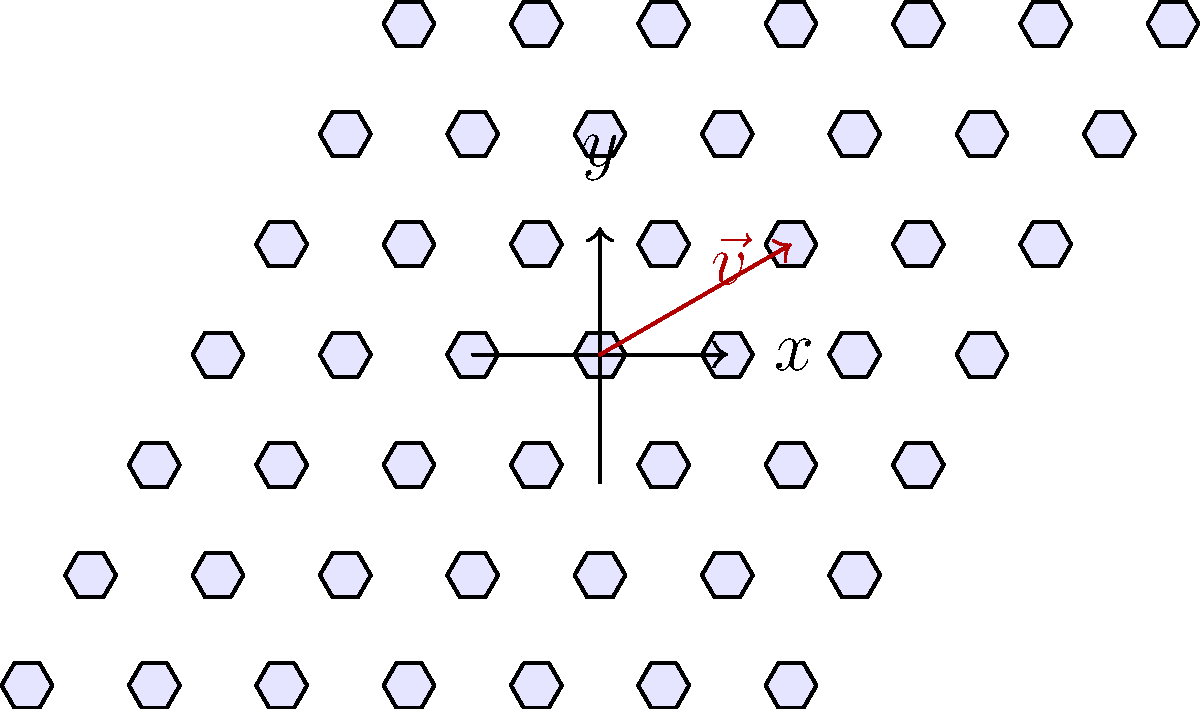In Islamic art, tessellating hexagonal patterns are often used in mosque tile designs. Consider the hexagonal tiling shown above. If we apply a translation by vector $\vec{v} = (1.5, 0.866)$ to this pattern, how many complete hexagons in the original pattern will be moved entirely outside the region shown in the diagram? To solve this problem, we need to analyze the effect of the translation vector on the hexagonal pattern:

1) First, observe that the hexagonal pattern is centered at the origin (0,0).

2) The translation vector $\vec{v} = (1.5, 0.866)$ moves the pattern 1.5 units in the x-direction and 0.866 units in the y-direction.

3) In the hexagonal tiling, each hexagon is surrounded by 6 others. The centers of these surrounding hexagons are at distances of 1 unit from the central hexagon.

4) The magnitude of the translation vector is:
   $\sqrt{1.5^2 + 0.866^2} \approx 1.732$

5) This magnitude is greater than the distance between the centers of adjacent hexagons (which is 1), but less than twice this distance.

6) This means that the translation will move hexagons beyond their immediate neighbors, but not beyond the second ring of hexagons.

7) Counting the hexagons that will be entirely moved out of the shown region:
   - 3 hexagons from the rightmost column
   - 2 hexagons from the second rightmost column
   - 1 hexagon from the third rightmost column

8) In total, 6 complete hexagons will be moved entirely outside the region shown.

This translation reflects the concept of infinite patterns in Islamic art, symbolizing the infinite nature of Allah's creation.
Answer: 6 hexagons 